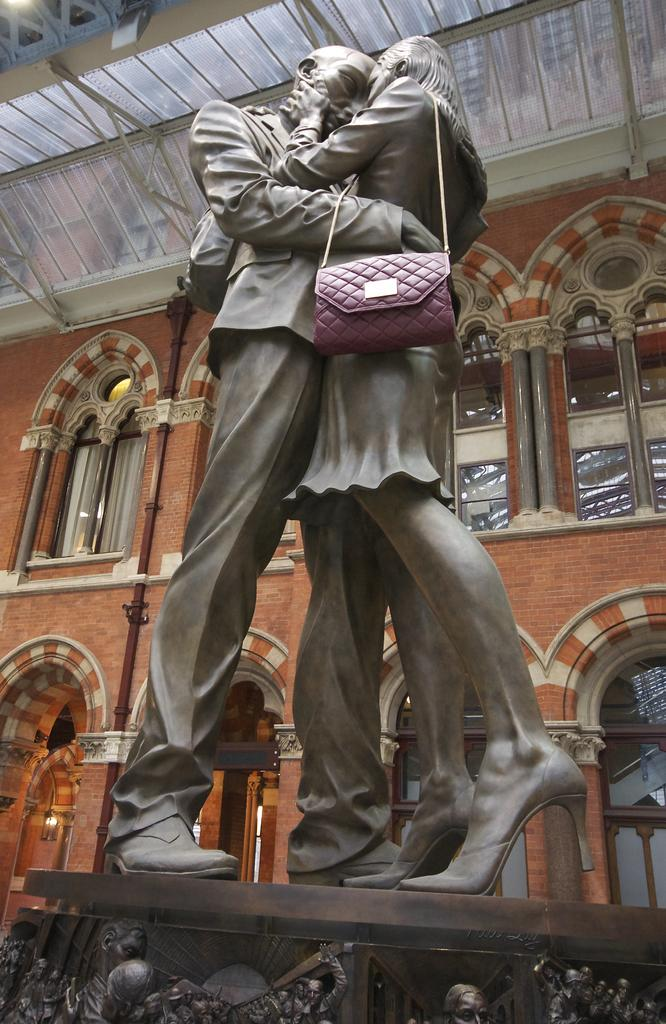What is the main subject in the image? There is a statue in the image. What can be seen behind the statue? There is an orange color building behind the statue. What type of pen is the statue holding in the image? There is no pen present in the image; the statue is not holding anything. 